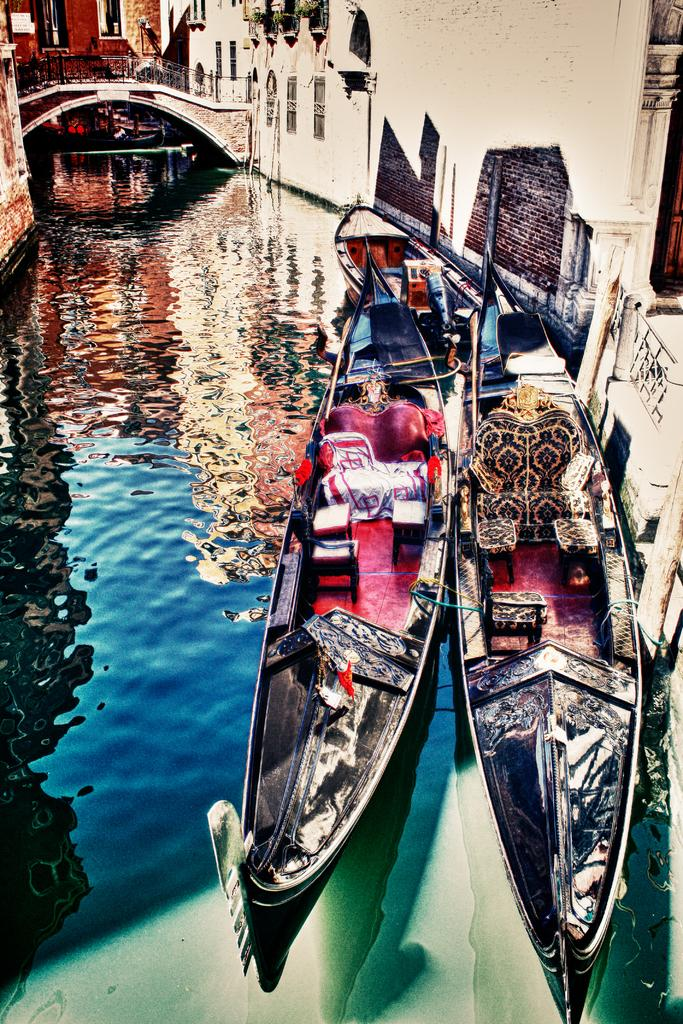What is the nature of the image? The image appears to be edited. What can be seen in the foreground of the image? There are boats and a canal in the foreground of the image. What type of structures are visible at the top of the image? There are buildings visible at the top of the image. What architectural feature is present in the image? There is a bridge in the image. What is located on the right side of the image? There is a well on the right side of the image. What type of chess piece is located on the bridge in the image? There is no chess piece present on the bridge in the image. How many hens can be seen in the image? There are no hens present in the image. 